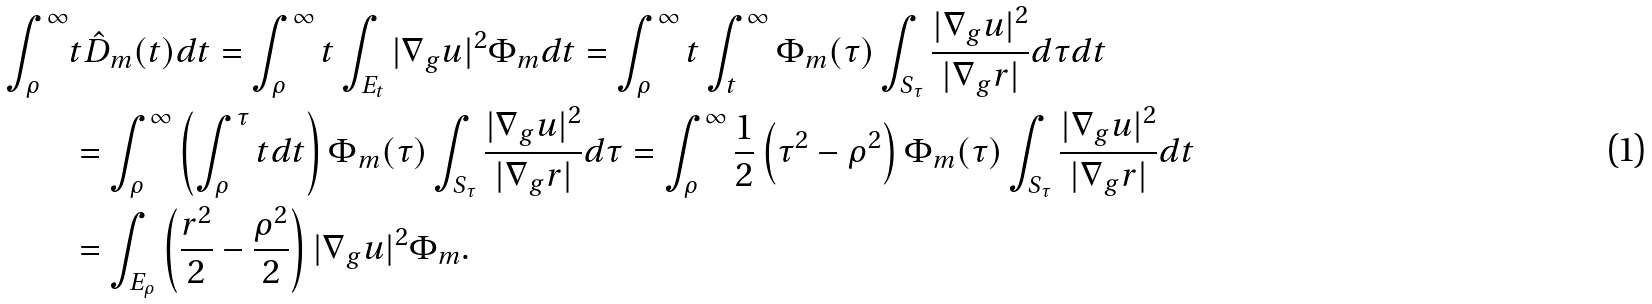<formula> <loc_0><loc_0><loc_500><loc_500>\int _ { \rho } ^ { \infty } & t \hat { D } _ { m } ( t ) d t = \int _ { \rho } ^ { \infty } t \int _ { E _ { t } } | \nabla _ { g } u | ^ { 2 } \Phi _ { m } d t = \int _ { \rho } ^ { \infty } t \int _ { t } ^ { \infty } \Phi _ { m } ( \tau ) \int _ { S _ { \tau } } \frac { | \nabla _ { g } u | ^ { 2 } } { | \nabla _ { g } r | } d \tau d t \\ & = \int _ { \rho } ^ { \infty } \left ( \int _ { \rho } ^ { \tau } t d t \right ) \Phi _ { m } ( \tau ) \int _ { S _ { \tau } } \frac { | \nabla _ { g } u | ^ { 2 } } { | \nabla _ { g } r | } d \tau = \int _ { \rho } ^ { \infty } \frac { 1 } { 2 } \left ( \tau ^ { 2 } - \rho ^ { 2 } \right ) \Phi _ { m } ( \tau ) \int _ { S _ { \tau } } \frac { | \nabla _ { g } u | ^ { 2 } } { | \nabla _ { g } r | } d t \\ & = \int _ { E _ { \rho } } \left ( \frac { r ^ { 2 } } { 2 } - \frac { \rho ^ { 2 } } { 2 } \right ) | \nabla _ { g } u | ^ { 2 } \Phi _ { m } . \\</formula> 